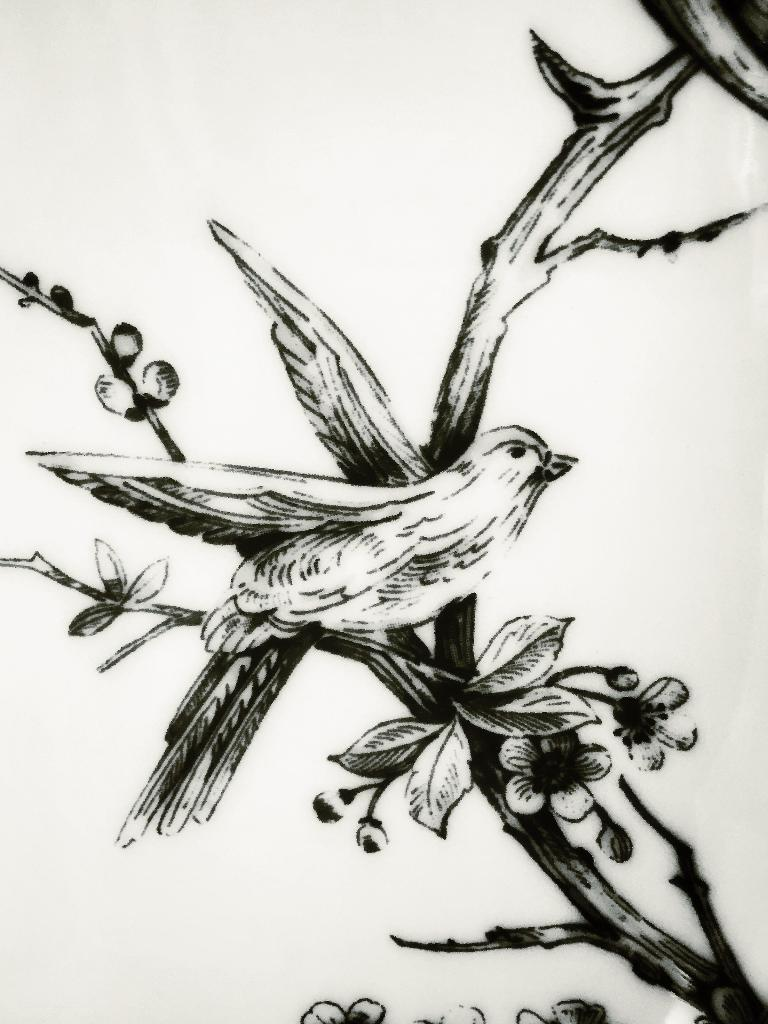What type of animal can be seen in the image? There is a bird in the image. Where is the bird located in the image? The bird is depicted on a tree. What type of story is the bird telling in the image? There is no indication in the image that the bird is telling a story, as it is a static image and does not depict any action or communication. 